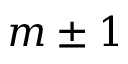Convert formula to latex. <formula><loc_0><loc_0><loc_500><loc_500>m \pm 1</formula> 